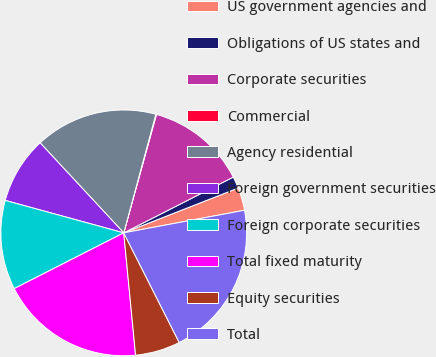Convert chart to OTSL. <chart><loc_0><loc_0><loc_500><loc_500><pie_chart><fcel>US government agencies and<fcel>Obligations of US states and<fcel>Corporate securities<fcel>Commercial<fcel>Agency residential<fcel>Foreign government securities<fcel>Foreign corporate securities<fcel>Total fixed maturity<fcel>Equity securities<fcel>Total<nl><fcel>3.0%<fcel>1.55%<fcel>13.21%<fcel>0.09%<fcel>16.12%<fcel>8.83%<fcel>11.75%<fcel>19.04%<fcel>5.92%<fcel>20.49%<nl></chart> 